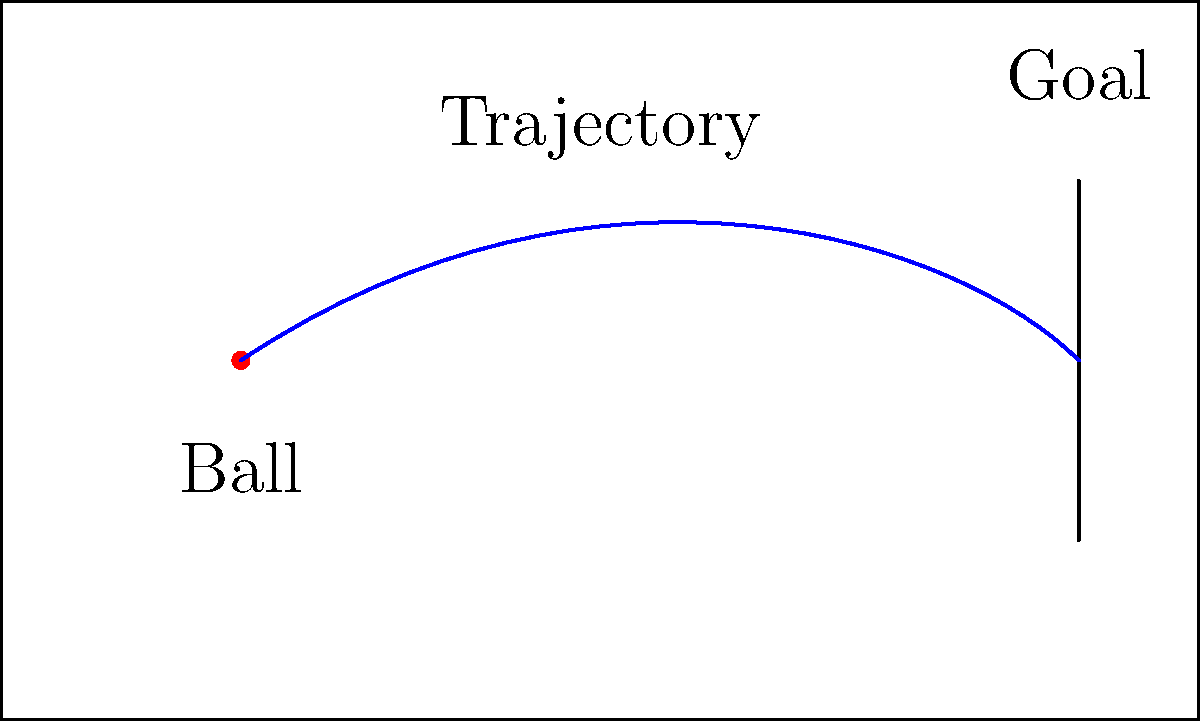In a crucial match against Argentina, you're tasked with taking a free kick from the position shown in the diagram. Considering the wind conditions and your experience with Wilson Mano's legendary free-kick technique, which path should the ball follow to have the highest probability of scoring? Explain your reasoning based on the diagram. To determine the optimal trajectory for the free kick, we need to consider several factors:

1. Initial position: The ball is placed at a considerable distance from the goal, slightly to the left of the center.

2. Curl: Given the initial position, a right-footed player (like many Brazilian players) would likely attempt to curl the ball from left to right.

3. Height: The trajectory should have enough height to clear any potential wall of defenders, but not so high that it goes over the crossbar.

4. Speed: The kick needs to be powerful enough to reach the goal but not so fast that it becomes difficult to control.

5. Wilson Mano's technique: Known for his precision and ability to bend the ball, we should incorporate a curved trajectory.

6. Wind conditions: Assuming minimal wind interference, we can focus on the ideal curve of the ball.

Based on these factors, the optimal trajectory would be:

- Start with a slight upward angle to clear the defensive wall.
- Curve from left to right, utilizing the spin imparted by a right-footed kick.
- Aim for the top right corner of the goal, making it difficult for the goalkeeper to reach.

The blue curve in the diagram represents this ideal trajectory, starting from the initial position, arcing upwards and to the right, and then dipping down towards the goal. This path maximizes the chances of scoring by combining height, curve, and precision.
Answer: Curved trajectory from left to right, aiming for the top right corner of the goal. 